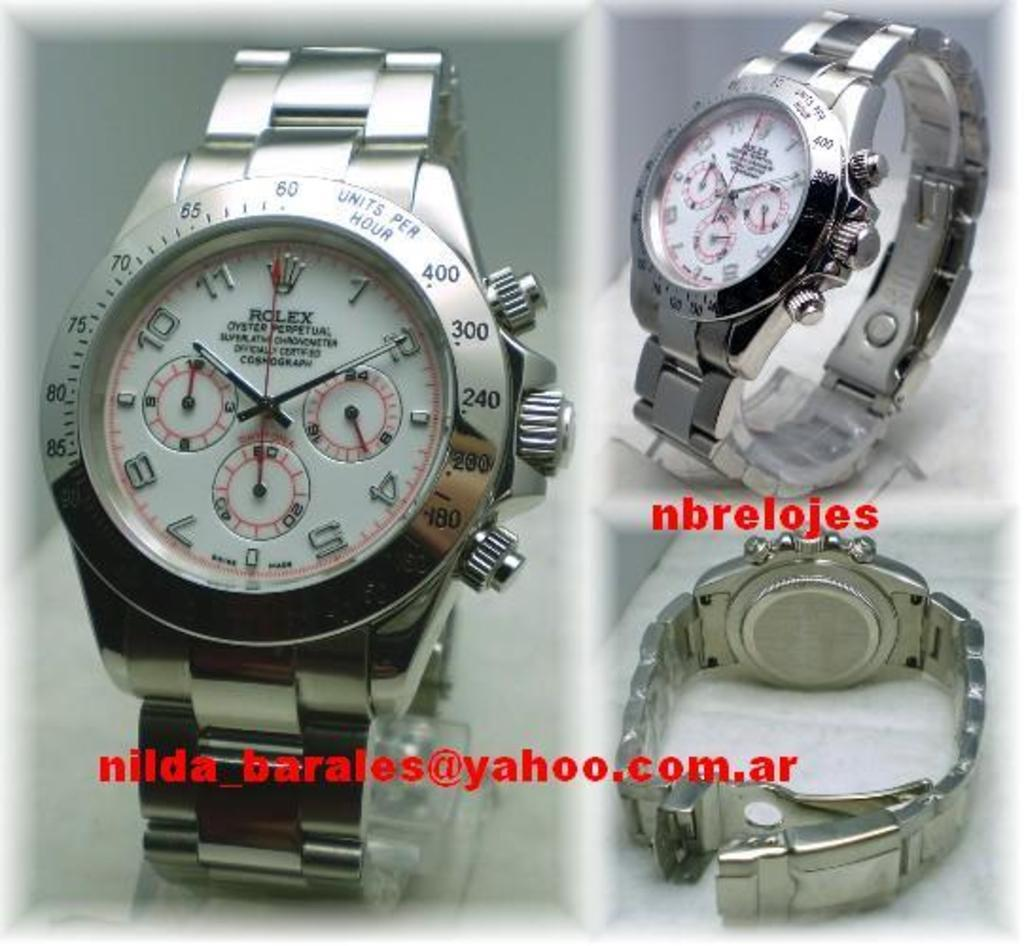<image>
Share a concise interpretation of the image provided. Collage of photos for a watch which has the word ROLEX on it. 